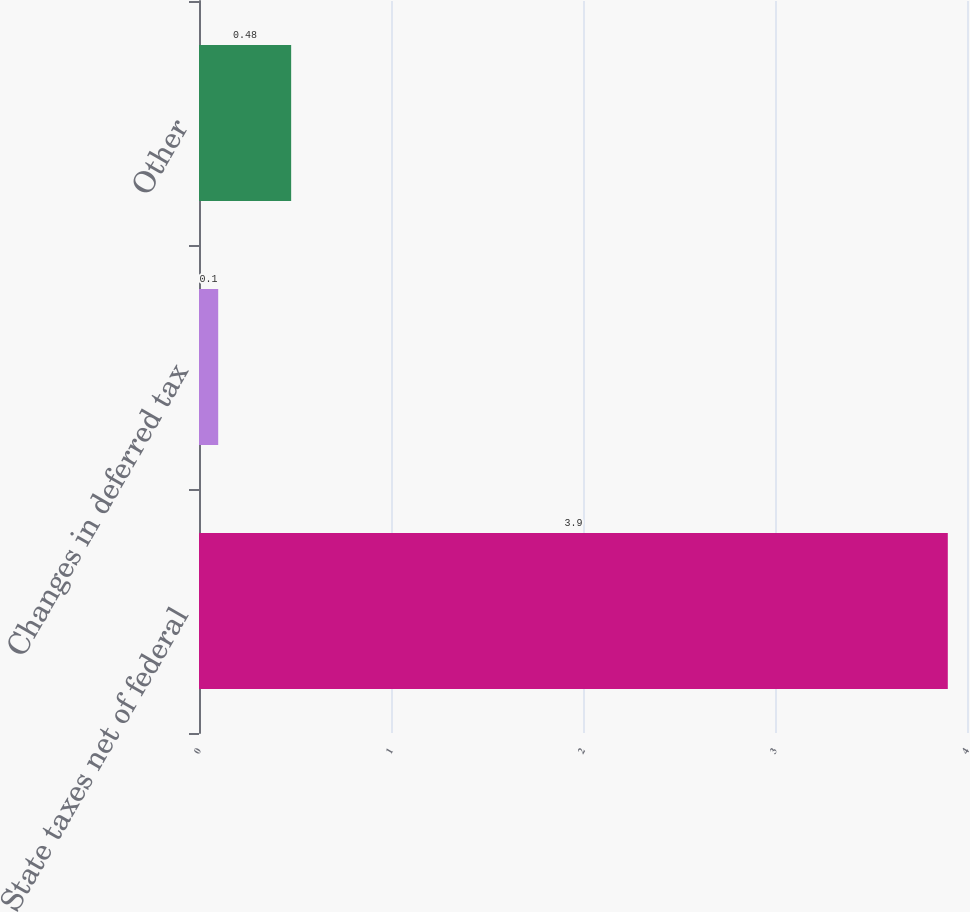Convert chart. <chart><loc_0><loc_0><loc_500><loc_500><bar_chart><fcel>State taxes net of federal<fcel>Changes in deferred tax<fcel>Other<nl><fcel>3.9<fcel>0.1<fcel>0.48<nl></chart> 